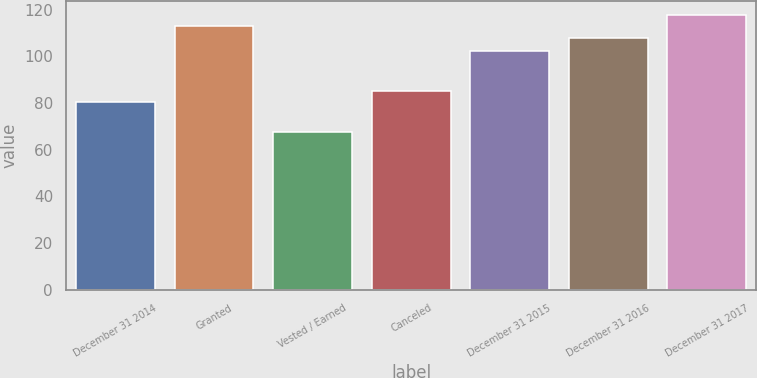Convert chart. <chart><loc_0><loc_0><loc_500><loc_500><bar_chart><fcel>December 31 2014<fcel>Granted<fcel>Vested / Earned<fcel>Canceled<fcel>December 31 2015<fcel>December 31 2016<fcel>December 31 2017<nl><fcel>80.33<fcel>112.9<fcel>67.7<fcel>85.23<fcel>102.49<fcel>107.95<fcel>117.8<nl></chart> 